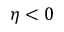<formula> <loc_0><loc_0><loc_500><loc_500>\eta < 0</formula> 